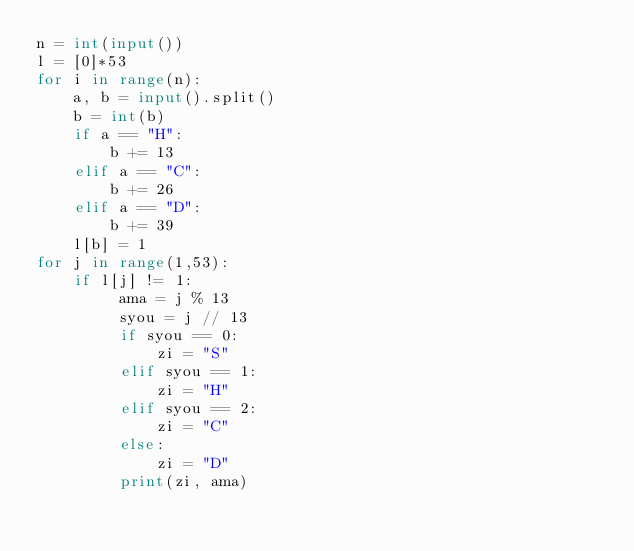Convert code to text. <code><loc_0><loc_0><loc_500><loc_500><_Python_>n = int(input())
l = [0]*53
for i in range(n):
    a, b = input().split()
    b = int(b)
    if a == "H":
        b += 13
    elif a == "C":
        b += 26
    elif a == "D":
        b += 39
    l[b] = 1 
for j in range(1,53):
    if l[j] != 1:
         ama = j % 13
         syou = j // 13
         if syou == 0:
             zi = "S"
         elif syou == 1:
             zi = "H"
         elif syou == 2:
             zi = "C"
         else:
             zi = "D"
         print(zi, ama)</code> 